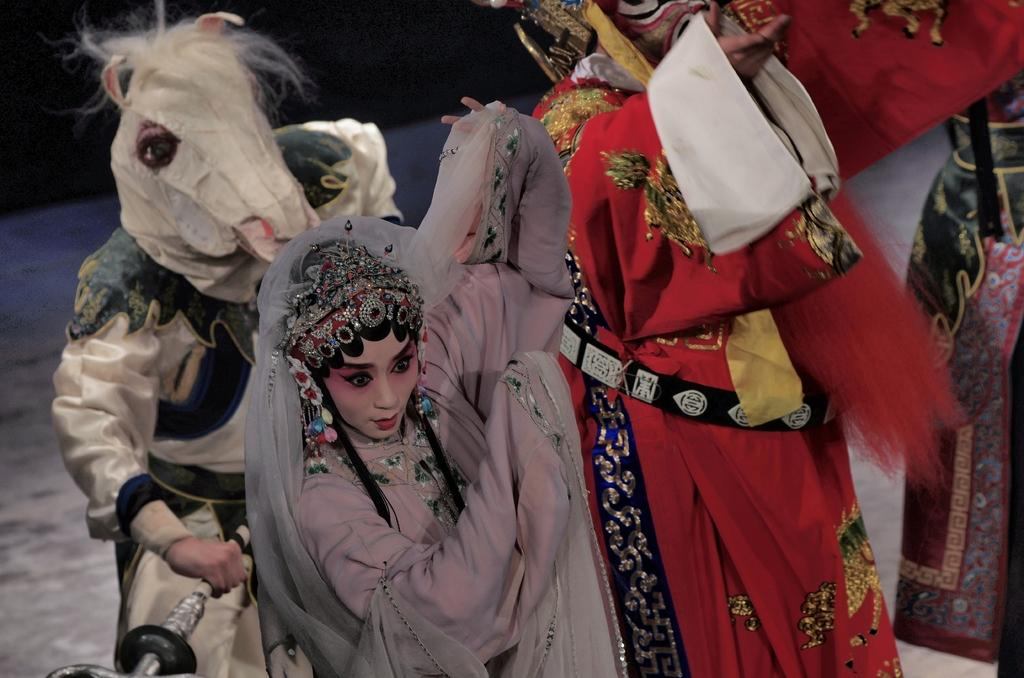What type of objects are depicted in the image? There are sculptures of persons in the image. What can be observed about the appearance of the sculptures? The sculptures have costumes on them. What type of scent can be detected from the sculptures in the image? There is no mention of a scent in the image, as it features sculptures with costumes. 